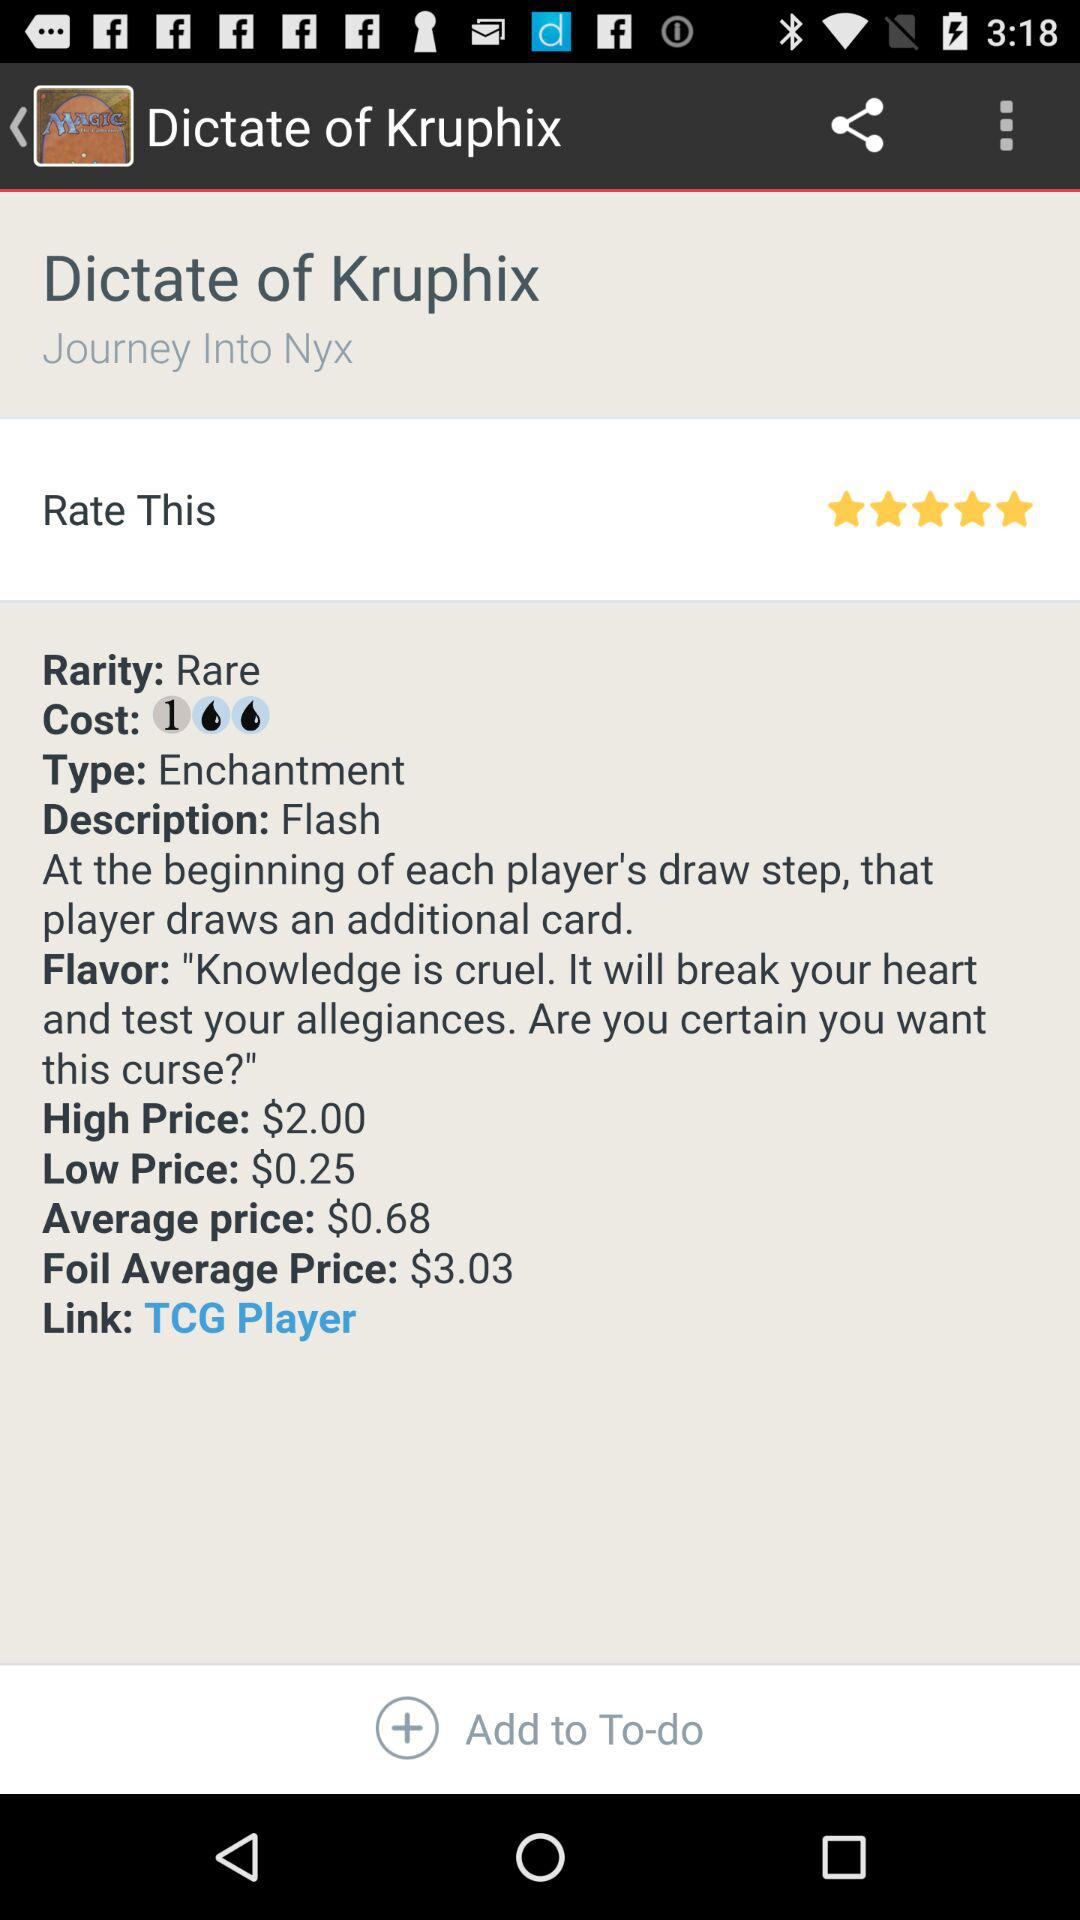What is the type of "Dictate of Kruphix"? The type of "Dictate of Kruphix" is enchantment. 